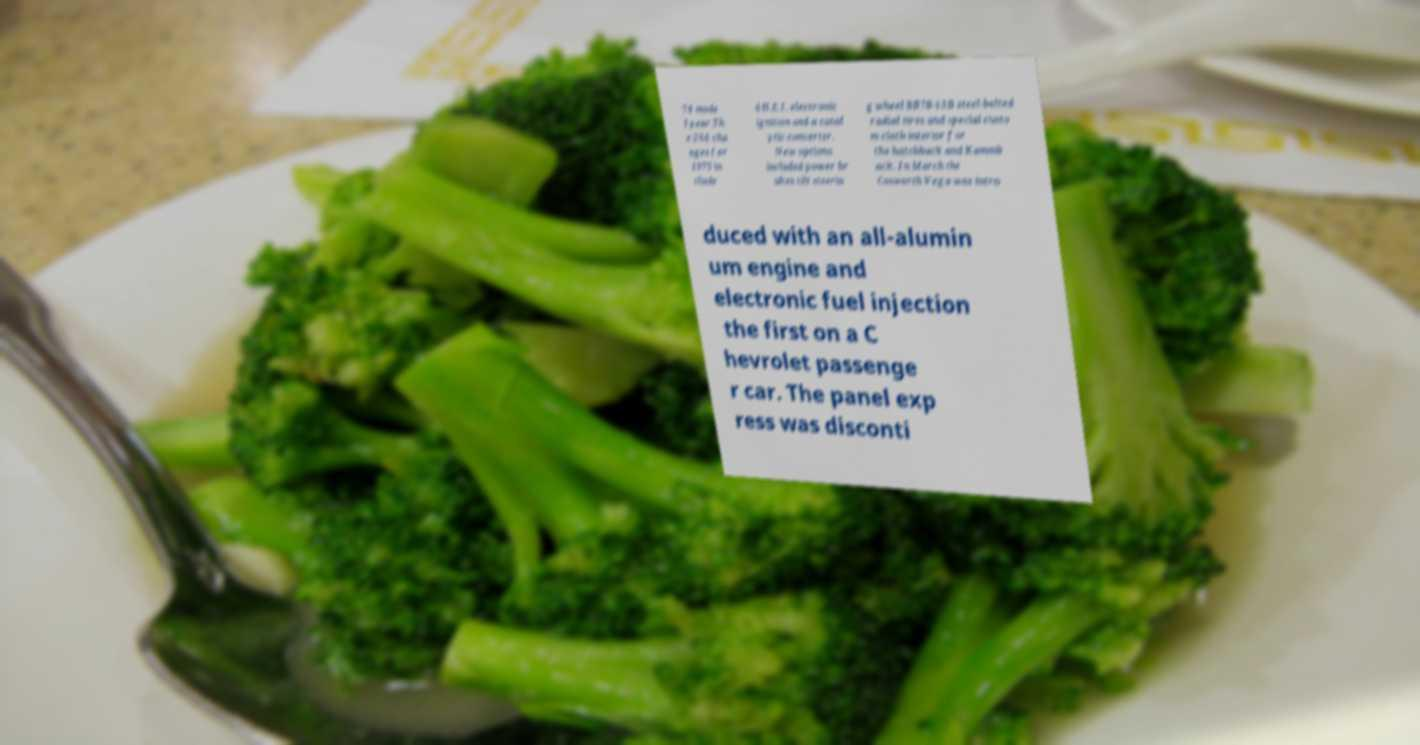Please read and relay the text visible in this image. What does it say? 74 mode l year.Th e 264 cha nges for 1975 in clude d H.E.I. electronic ignition and a catal ytic converter. New options included power br akes tilt steerin g wheel BR78-13B steel-belted radial tires and special custo m cloth interior for the hatchback and Kammb ack. In March the Cosworth Vega was intro duced with an all-alumin um engine and electronic fuel injection the first on a C hevrolet passenge r car. The panel exp ress was disconti 